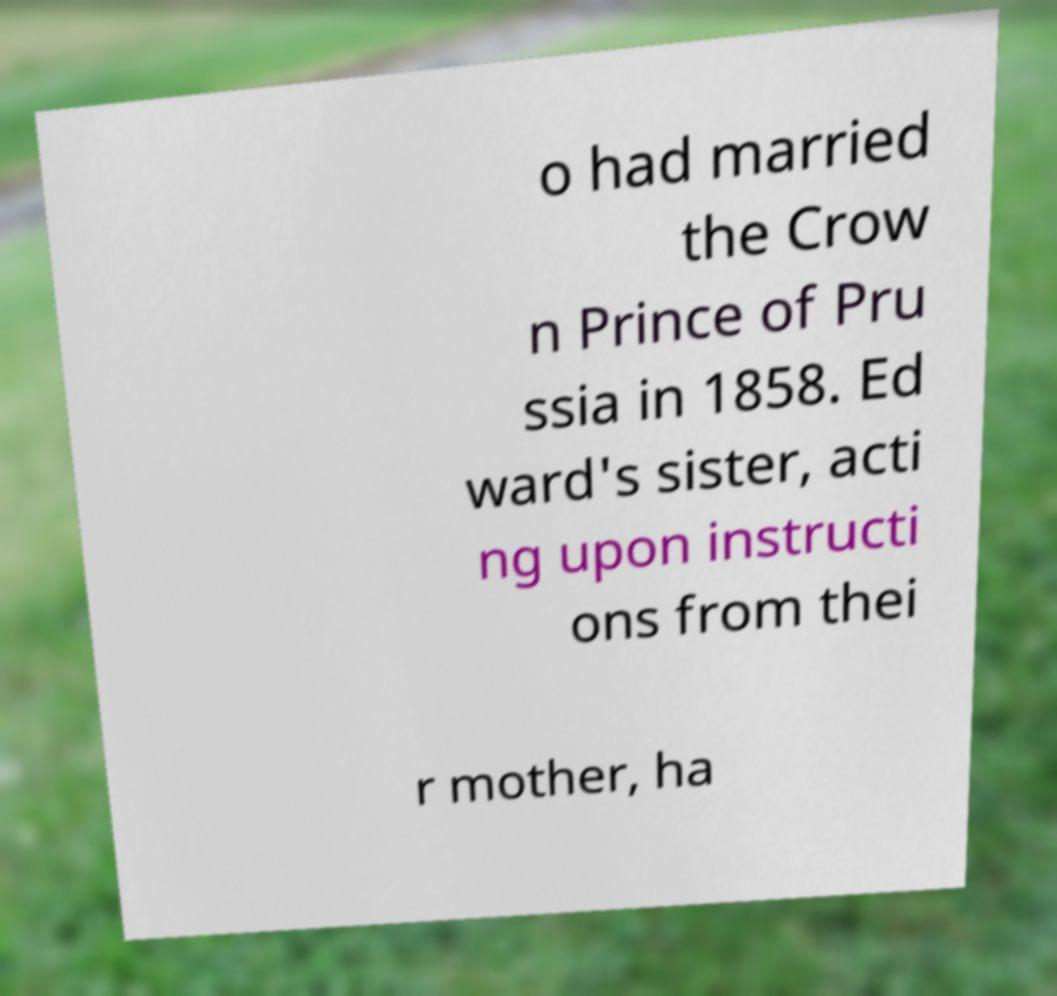What messages or text are displayed in this image? I need them in a readable, typed format. o had married the Crow n Prince of Pru ssia in 1858. Ed ward's sister, acti ng upon instructi ons from thei r mother, ha 